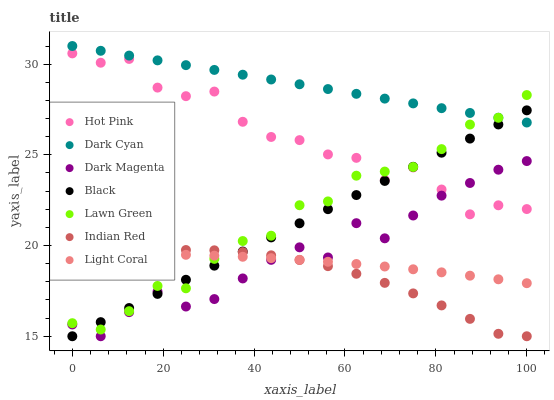Does Indian Red have the minimum area under the curve?
Answer yes or no. Yes. Does Dark Cyan have the maximum area under the curve?
Answer yes or no. Yes. Does Dark Magenta have the minimum area under the curve?
Answer yes or no. No. Does Dark Magenta have the maximum area under the curve?
Answer yes or no. No. Is Dark Cyan the smoothest?
Answer yes or no. Yes. Is Hot Pink the roughest?
Answer yes or no. Yes. Is Dark Magenta the smoothest?
Answer yes or no. No. Is Dark Magenta the roughest?
Answer yes or no. No. Does Dark Magenta have the lowest value?
Answer yes or no. Yes. Does Hot Pink have the lowest value?
Answer yes or no. No. Does Dark Cyan have the highest value?
Answer yes or no. Yes. Does Dark Magenta have the highest value?
Answer yes or no. No. Is Hot Pink less than Dark Cyan?
Answer yes or no. Yes. Is Dark Cyan greater than Hot Pink?
Answer yes or no. Yes. Does Dark Cyan intersect Lawn Green?
Answer yes or no. Yes. Is Dark Cyan less than Lawn Green?
Answer yes or no. No. Is Dark Cyan greater than Lawn Green?
Answer yes or no. No. Does Hot Pink intersect Dark Cyan?
Answer yes or no. No. 